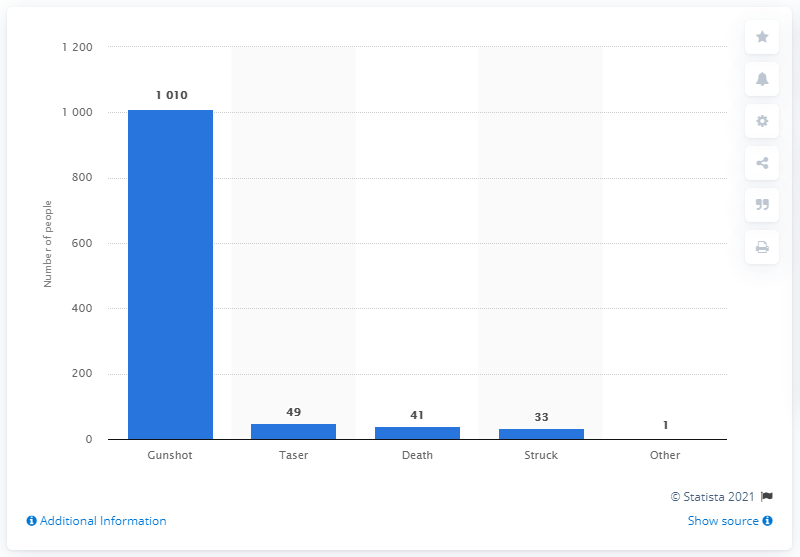Draw attention to some important aspects in this diagram. In 2015, 33 people were killed by police. 